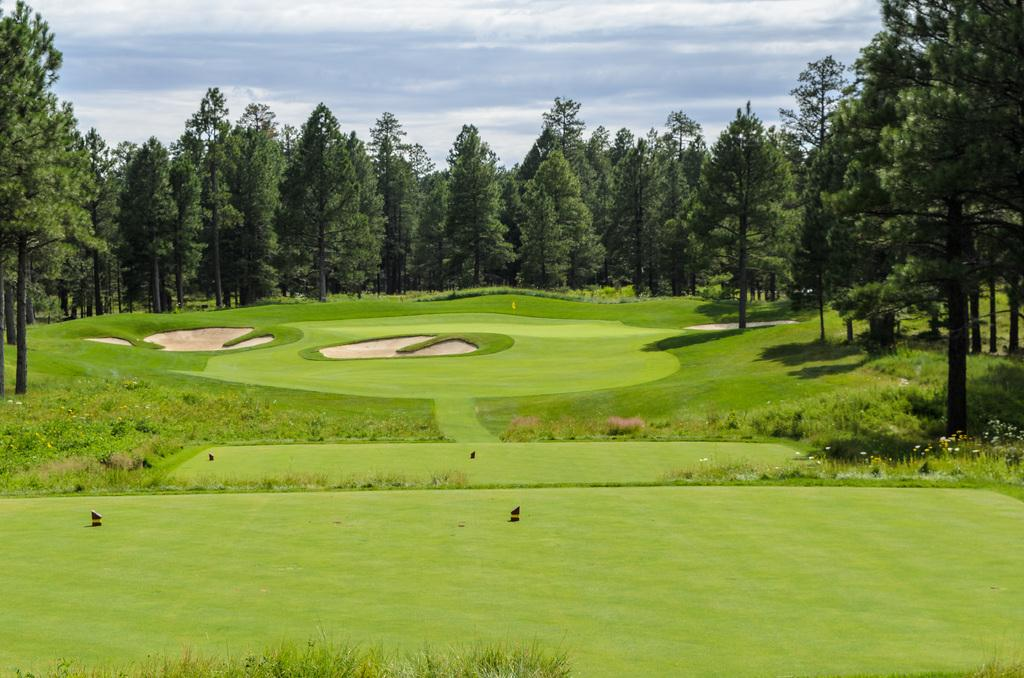What type of environment might the image be taken in? The image might be taken in a golf court. What type of ground surface is visible in the image? There is grass in the image. What type of vegetation can be seen in the image? There are plants and trees in the image. What is visible in the sky in the image? The sky is visible in the image, and clouds are present. What type of credit can be seen being given to the players in the image? There is no credit being given to any players in the image, as it does not depict a scene where credit is typically given. 